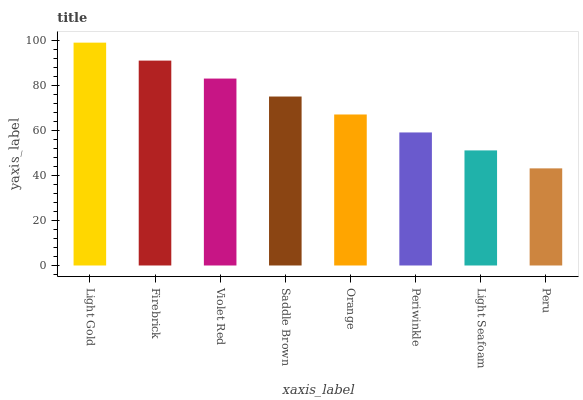Is Peru the minimum?
Answer yes or no. Yes. Is Light Gold the maximum?
Answer yes or no. Yes. Is Firebrick the minimum?
Answer yes or no. No. Is Firebrick the maximum?
Answer yes or no. No. Is Light Gold greater than Firebrick?
Answer yes or no. Yes. Is Firebrick less than Light Gold?
Answer yes or no. Yes. Is Firebrick greater than Light Gold?
Answer yes or no. No. Is Light Gold less than Firebrick?
Answer yes or no. No. Is Saddle Brown the high median?
Answer yes or no. Yes. Is Orange the low median?
Answer yes or no. Yes. Is Violet Red the high median?
Answer yes or no. No. Is Light Seafoam the low median?
Answer yes or no. No. 